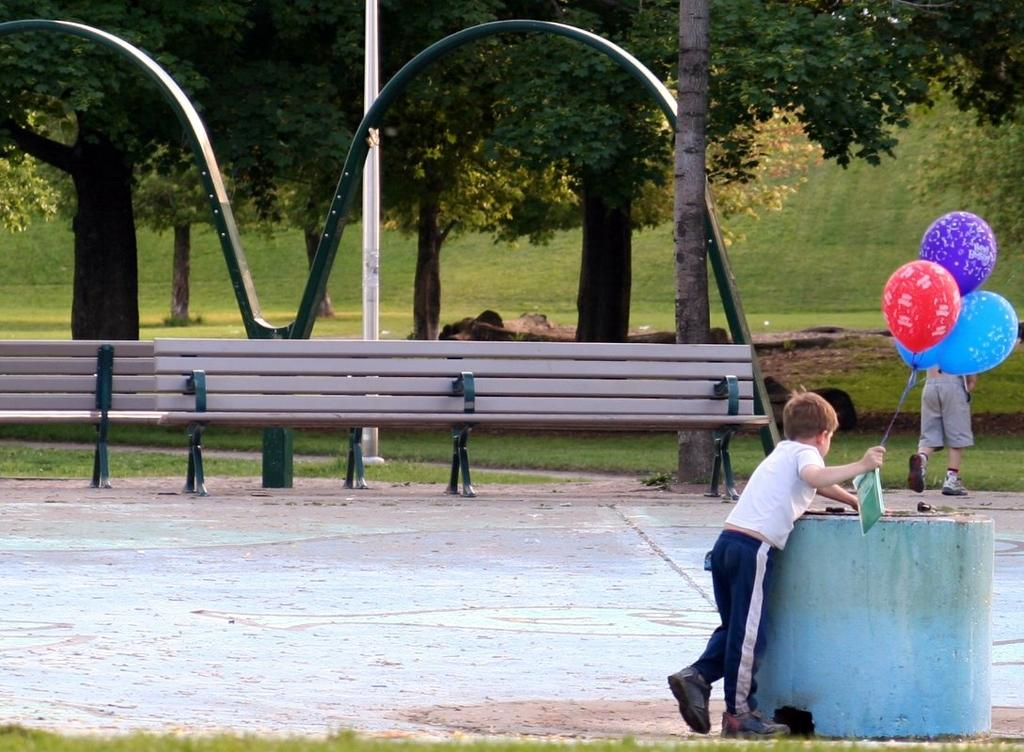Where is the boy located in the image? The boy is on the right side of the image. What is the boy wearing? The boy is wearing a t-shirt, trousers, and shoes. What is the boy holding in his right hand? The boy is holding balloons in his right hand. What can be seen in the middle of the image? There are benches and trees in the middle of the image. What type of table is being used as a prop for the boy's impulse to jump in the image? There is no table present in the image, and the boy is not shown jumping. 